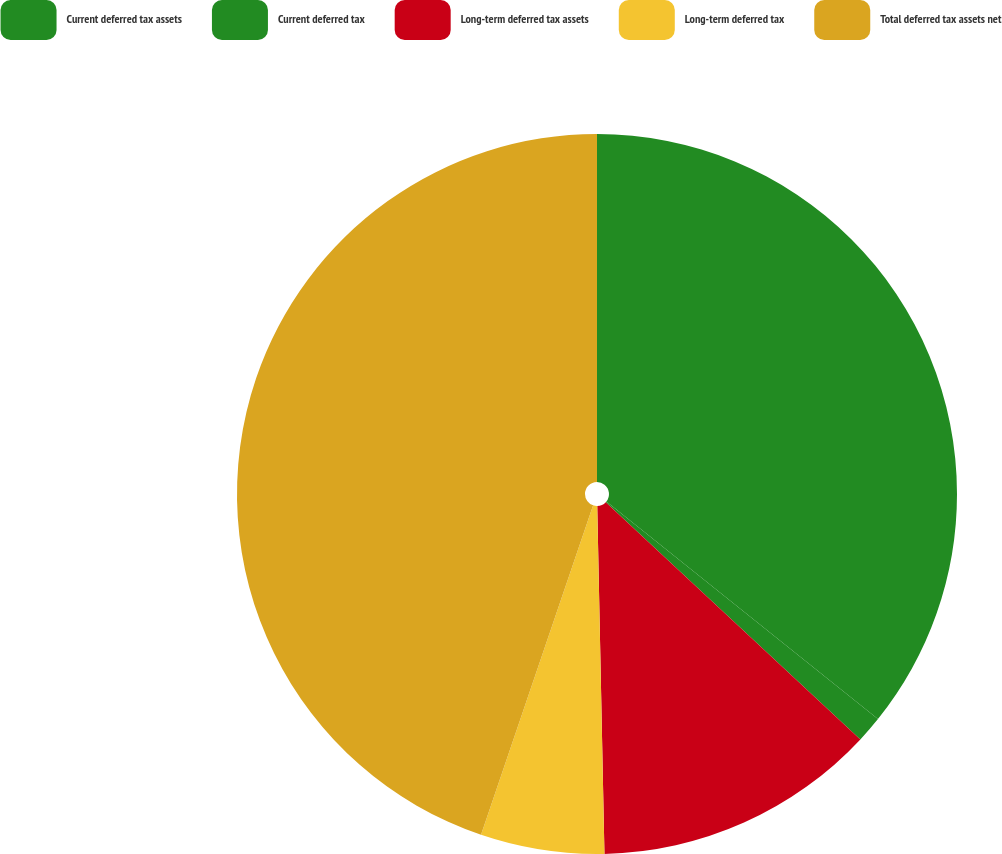<chart> <loc_0><loc_0><loc_500><loc_500><pie_chart><fcel>Current deferred tax assets<fcel>Current deferred tax<fcel>Long-term deferred tax assets<fcel>Long-term deferred tax<fcel>Total deferred tax assets net<nl><fcel>35.75%<fcel>1.19%<fcel>12.73%<fcel>5.55%<fcel>44.78%<nl></chart> 